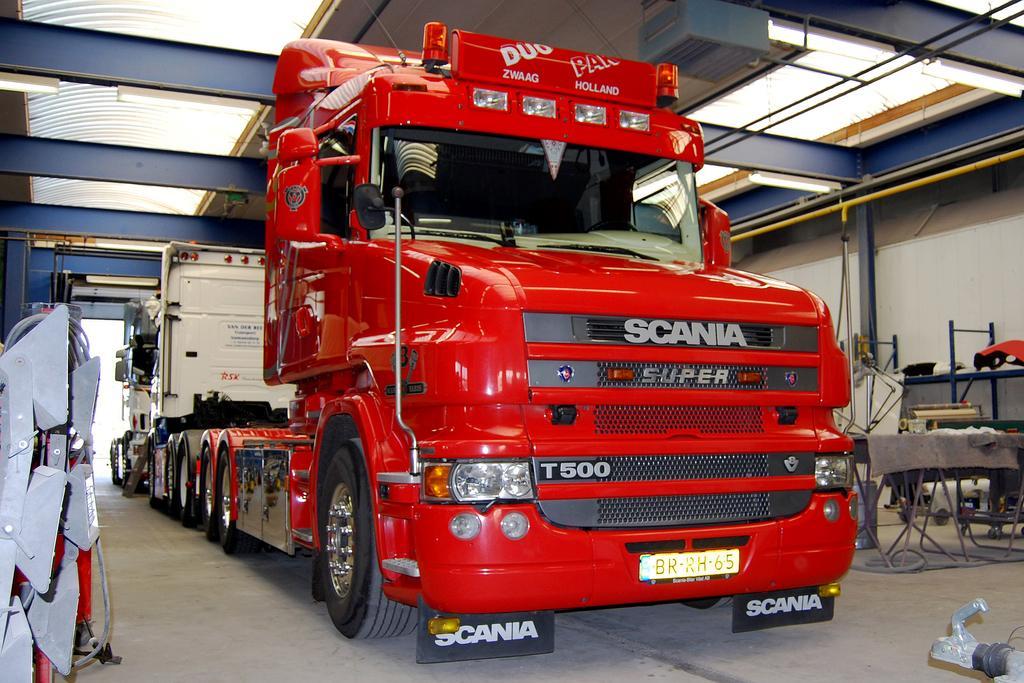Please provide a concise description of this image. In this picture there is a truck in the center of the image, which is red in color and there is a table on the right side of the image. 